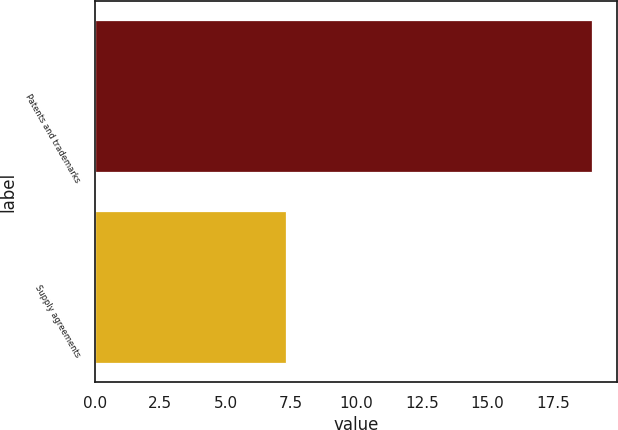Convert chart to OTSL. <chart><loc_0><loc_0><loc_500><loc_500><bar_chart><fcel>Patents and trademarks<fcel>Supply agreements<nl><fcel>19<fcel>7.3<nl></chart> 